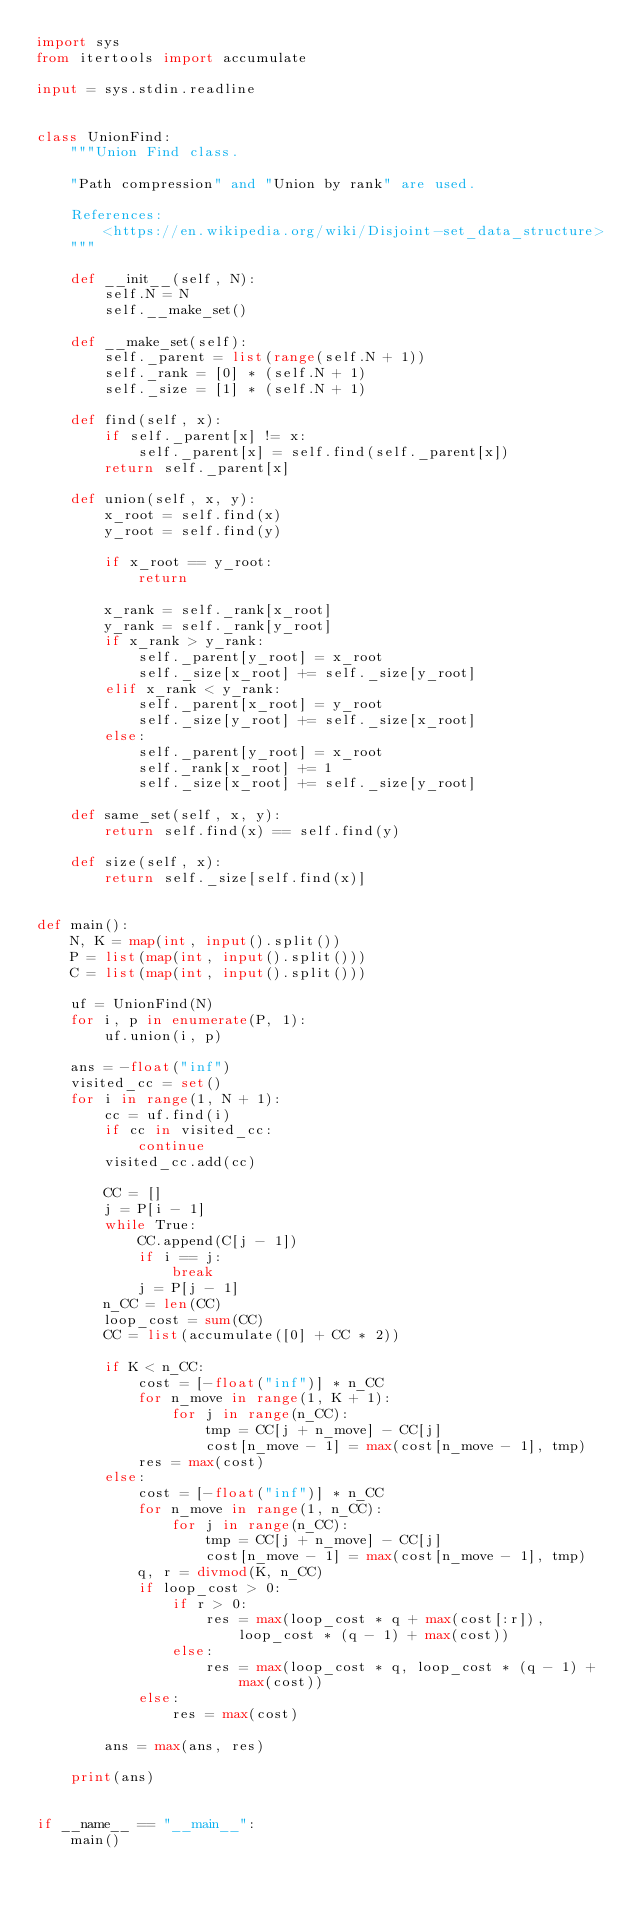Convert code to text. <code><loc_0><loc_0><loc_500><loc_500><_Python_>import sys
from itertools import accumulate

input = sys.stdin.readline


class UnionFind:
    """Union Find class.

    "Path compression" and "Union by rank" are used.

    References:
        <https://en.wikipedia.org/wiki/Disjoint-set_data_structure>
    """

    def __init__(self, N):
        self.N = N
        self.__make_set()

    def __make_set(self):
        self._parent = list(range(self.N + 1))
        self._rank = [0] * (self.N + 1)
        self._size = [1] * (self.N + 1)

    def find(self, x):
        if self._parent[x] != x:
            self._parent[x] = self.find(self._parent[x])
        return self._parent[x]

    def union(self, x, y):
        x_root = self.find(x)
        y_root = self.find(y)

        if x_root == y_root:
            return

        x_rank = self._rank[x_root]
        y_rank = self._rank[y_root]
        if x_rank > y_rank:
            self._parent[y_root] = x_root
            self._size[x_root] += self._size[y_root]
        elif x_rank < y_rank:
            self._parent[x_root] = y_root
            self._size[y_root] += self._size[x_root]
        else:
            self._parent[y_root] = x_root
            self._rank[x_root] += 1
            self._size[x_root] += self._size[y_root]

    def same_set(self, x, y):
        return self.find(x) == self.find(y)

    def size(self, x):
        return self._size[self.find(x)]


def main():
    N, K = map(int, input().split())
    P = list(map(int, input().split()))
    C = list(map(int, input().split()))

    uf = UnionFind(N)
    for i, p in enumerate(P, 1):
        uf.union(i, p)

    ans = -float("inf")
    visited_cc = set()
    for i in range(1, N + 1):
        cc = uf.find(i)
        if cc in visited_cc:
            continue
        visited_cc.add(cc)

        CC = []
        j = P[i - 1]
        while True:
            CC.append(C[j - 1])
            if i == j:
                break
            j = P[j - 1]
        n_CC = len(CC)
        loop_cost = sum(CC)
        CC = list(accumulate([0] + CC * 2))

        if K < n_CC:
            cost = [-float("inf")] * n_CC
            for n_move in range(1, K + 1):
                for j in range(n_CC):
                    tmp = CC[j + n_move] - CC[j]
                    cost[n_move - 1] = max(cost[n_move - 1], tmp)
            res = max(cost)
        else:
            cost = [-float("inf")] * n_CC
            for n_move in range(1, n_CC):
                for j in range(n_CC):
                    tmp = CC[j + n_move] - CC[j]
                    cost[n_move - 1] = max(cost[n_move - 1], tmp)
            q, r = divmod(K, n_CC)
            if loop_cost > 0:
                if r > 0:
                    res = max(loop_cost * q + max(cost[:r]), loop_cost * (q - 1) + max(cost))
                else:
                    res = max(loop_cost * q, loop_cost * (q - 1) + max(cost))
            else:
                res = max(cost)

        ans = max(ans, res)

    print(ans)


if __name__ == "__main__":
    main()
</code> 